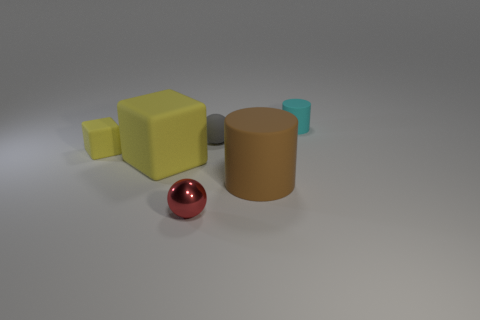There is a big yellow object; are there any tiny red balls in front of it?
Your response must be concise. Yes. What color is the block that is the same size as the brown rubber cylinder?
Offer a very short reply. Yellow. How many large green cylinders are made of the same material as the big yellow object?
Keep it short and to the point. 0. How many other objects are the same size as the cyan object?
Keep it short and to the point. 3. Are there any blue matte cylinders of the same size as the red shiny sphere?
Your response must be concise. No. Do the large thing that is behind the brown matte thing and the big rubber cylinder have the same color?
Keep it short and to the point. No. How many objects are rubber blocks or small gray metallic balls?
Your response must be concise. 2. There is a ball to the right of the shiny ball; is its size the same as the large brown thing?
Your answer should be compact. No. What is the size of the object that is to the right of the red sphere and in front of the small gray thing?
Give a very brief answer. Large. How many other objects are the same shape as the small red metal object?
Offer a very short reply. 1. 